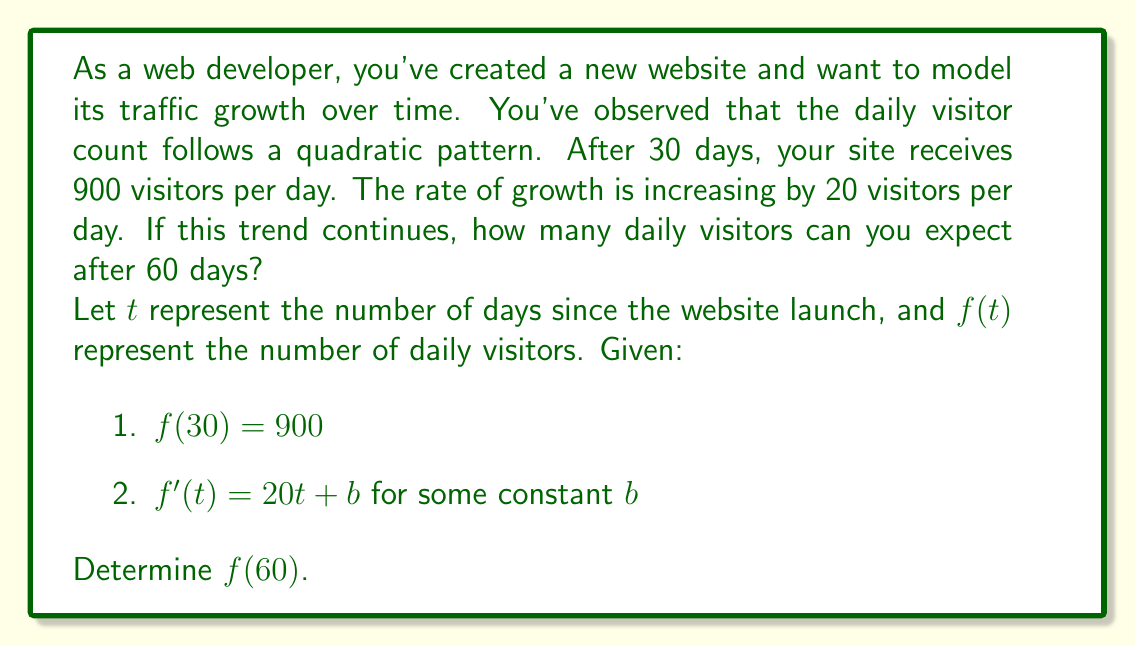Give your solution to this math problem. Let's approach this step-by-step:

1) We know the function is quadratic, so it has the general form:
   $$f(t) = at^2 + bt + c$$

2) The derivative of this function is:
   $$f'(t) = 2at + b$$

3) We're given that $f'(t) = 20t + b$, so we can deduce that $a = 10$.

4) Now our function looks like:
   $$f(t) = 10t^2 + bt + c$$

5) We're given that $f(30) = 900$. Let's use this:
   $$900 = 10(30)^2 + 30b + c$$
   $$900 = 9000 + 30b + c$$

6) We need another equation to solve for $b$ and $c$. We can use the fact that the site started with 0 visitors:
   $$f(0) = 0$$
   $$0 = 10(0)^2 + b(0) + c$$
   $$c = 0$$

7) Substituting this back into the equation from step 5:
   $$900 = 9000 + 30b$$
   $$-8100 = 30b$$
   $$b = -270$$

8) Now we have our complete function:
   $$f(t) = 10t^2 - 270t$$

9) To find the number of visitors after 60 days, we calculate $f(60)$:
   $$f(60) = 10(60)^2 - 270(60)$$
   $$f(60) = 36000 - 16200$$
   $$f(60) = 19800$$
Answer: After 60 days, you can expect 19,800 daily visitors to your website. 